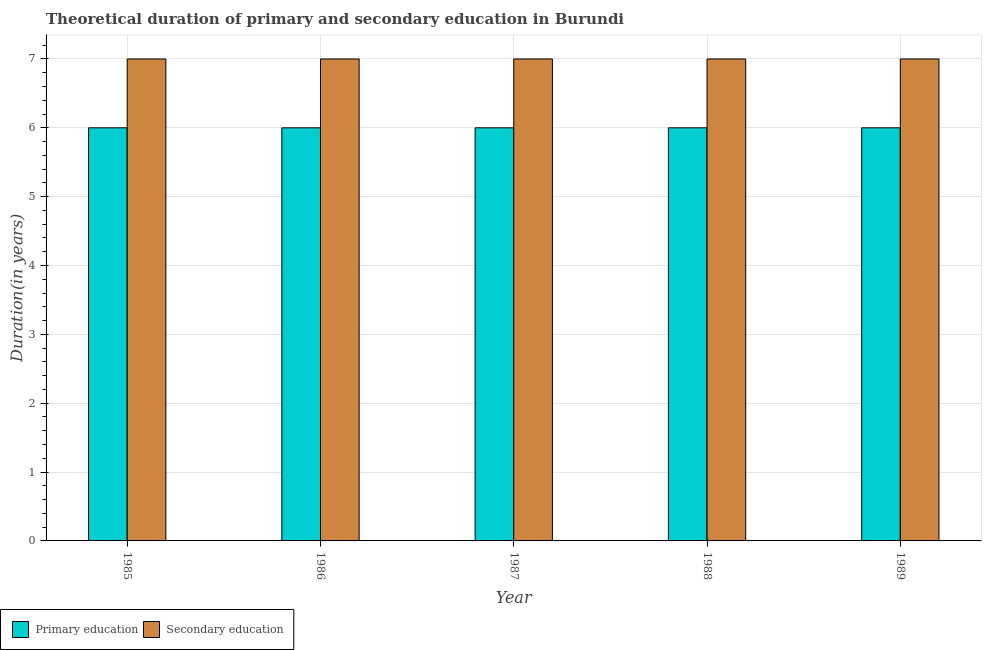Are the number of bars on each tick of the X-axis equal?
Your answer should be very brief. Yes. What is the label of the 1st group of bars from the left?
Make the answer very short. 1985. In how many cases, is the number of bars for a given year not equal to the number of legend labels?
Provide a succinct answer. 0. What is the duration of secondary education in 1985?
Make the answer very short. 7. Across all years, what is the maximum duration of secondary education?
Give a very brief answer. 7. In which year was the duration of secondary education maximum?
Provide a short and direct response. 1985. In which year was the duration of primary education minimum?
Offer a very short reply. 1985. What is the total duration of secondary education in the graph?
Your answer should be very brief. 35. What is the difference between the duration of primary education in 1986 and that in 1987?
Your response must be concise. 0. In how many years, is the duration of secondary education greater than 5.8 years?
Your answer should be very brief. 5. What is the ratio of the duration of secondary education in 1986 to that in 1988?
Offer a very short reply. 1. Is the duration of secondary education in 1987 less than that in 1989?
Your answer should be very brief. No. What is the difference between the highest and the lowest duration of secondary education?
Provide a short and direct response. 0. In how many years, is the duration of primary education greater than the average duration of primary education taken over all years?
Ensure brevity in your answer.  0. What does the 2nd bar from the left in 1986 represents?
Provide a short and direct response. Secondary education. How many years are there in the graph?
Offer a very short reply. 5. What is the difference between two consecutive major ticks on the Y-axis?
Offer a very short reply. 1. Are the values on the major ticks of Y-axis written in scientific E-notation?
Make the answer very short. No. Where does the legend appear in the graph?
Provide a succinct answer. Bottom left. How are the legend labels stacked?
Offer a very short reply. Horizontal. What is the title of the graph?
Offer a terse response. Theoretical duration of primary and secondary education in Burundi. What is the label or title of the Y-axis?
Offer a terse response. Duration(in years). What is the Duration(in years) of Primary education in 1985?
Provide a succinct answer. 6. What is the Duration(in years) in Secondary education in 1985?
Provide a short and direct response. 7. What is the Duration(in years) of Primary education in 1988?
Provide a short and direct response. 6. Across all years, what is the maximum Duration(in years) in Primary education?
Your response must be concise. 6. Across all years, what is the maximum Duration(in years) in Secondary education?
Ensure brevity in your answer.  7. What is the total Duration(in years) in Primary education in the graph?
Give a very brief answer. 30. What is the difference between the Duration(in years) of Primary education in 1985 and that in 1986?
Make the answer very short. 0. What is the difference between the Duration(in years) in Secondary education in 1985 and that in 1986?
Your answer should be very brief. 0. What is the difference between the Duration(in years) of Primary education in 1985 and that in 1987?
Offer a very short reply. 0. What is the difference between the Duration(in years) in Secondary education in 1985 and that in 1987?
Offer a terse response. 0. What is the difference between the Duration(in years) in Primary education in 1985 and that in 1988?
Provide a short and direct response. 0. What is the difference between the Duration(in years) in Secondary education in 1985 and that in 1989?
Provide a short and direct response. 0. What is the difference between the Duration(in years) in Primary education in 1987 and that in 1988?
Offer a terse response. 0. What is the difference between the Duration(in years) in Primary education in 1987 and that in 1989?
Give a very brief answer. 0. What is the difference between the Duration(in years) in Secondary education in 1987 and that in 1989?
Provide a succinct answer. 0. What is the difference between the Duration(in years) in Primary education in 1988 and that in 1989?
Your answer should be compact. 0. What is the difference between the Duration(in years) in Secondary education in 1988 and that in 1989?
Provide a succinct answer. 0. What is the difference between the Duration(in years) of Primary education in 1985 and the Duration(in years) of Secondary education in 1986?
Your response must be concise. -1. What is the difference between the Duration(in years) of Primary education in 1985 and the Duration(in years) of Secondary education in 1989?
Your answer should be very brief. -1. What is the difference between the Duration(in years) of Primary education in 1986 and the Duration(in years) of Secondary education in 1987?
Give a very brief answer. -1. What is the difference between the Duration(in years) of Primary education in 1986 and the Duration(in years) of Secondary education in 1989?
Give a very brief answer. -1. What is the difference between the Duration(in years) in Primary education in 1987 and the Duration(in years) in Secondary education in 1988?
Keep it short and to the point. -1. What is the difference between the Duration(in years) of Primary education in 1987 and the Duration(in years) of Secondary education in 1989?
Ensure brevity in your answer.  -1. What is the difference between the Duration(in years) of Primary education in 1988 and the Duration(in years) of Secondary education in 1989?
Ensure brevity in your answer.  -1. What is the average Duration(in years) in Secondary education per year?
Give a very brief answer. 7. In the year 1985, what is the difference between the Duration(in years) of Primary education and Duration(in years) of Secondary education?
Provide a succinct answer. -1. In the year 1986, what is the difference between the Duration(in years) of Primary education and Duration(in years) of Secondary education?
Give a very brief answer. -1. In the year 1987, what is the difference between the Duration(in years) of Primary education and Duration(in years) of Secondary education?
Keep it short and to the point. -1. In the year 1988, what is the difference between the Duration(in years) of Primary education and Duration(in years) of Secondary education?
Give a very brief answer. -1. What is the ratio of the Duration(in years) of Secondary education in 1985 to that in 1986?
Offer a very short reply. 1. What is the ratio of the Duration(in years) of Primary education in 1985 to that in 1987?
Provide a succinct answer. 1. What is the ratio of the Duration(in years) in Secondary education in 1985 to that in 1988?
Provide a succinct answer. 1. What is the ratio of the Duration(in years) of Primary education in 1985 to that in 1989?
Provide a short and direct response. 1. What is the ratio of the Duration(in years) of Primary education in 1986 to that in 1989?
Make the answer very short. 1. What is the ratio of the Duration(in years) of Secondary education in 1986 to that in 1989?
Provide a succinct answer. 1. What is the ratio of the Duration(in years) in Secondary education in 1987 to that in 1988?
Provide a succinct answer. 1. What is the ratio of the Duration(in years) of Primary education in 1987 to that in 1989?
Provide a succinct answer. 1. What is the ratio of the Duration(in years) in Secondary education in 1988 to that in 1989?
Offer a terse response. 1. What is the difference between the highest and the second highest Duration(in years) in Secondary education?
Ensure brevity in your answer.  0. 